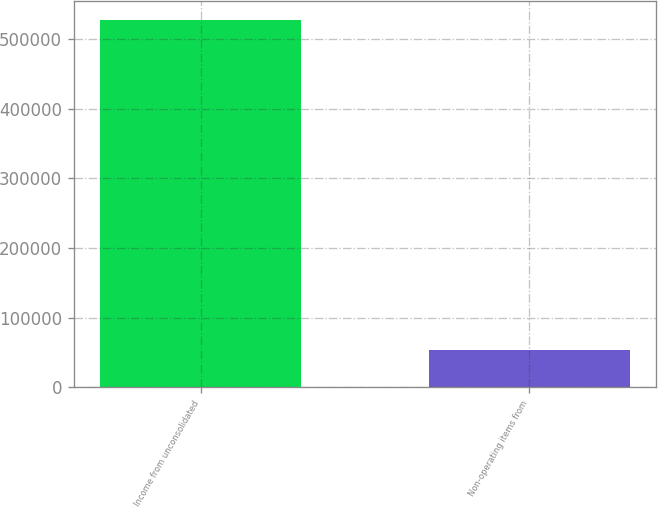<chart> <loc_0><loc_0><loc_500><loc_500><bar_chart><fcel>Income from unconsolidated<fcel>Non-operating items from<nl><fcel>527616<fcel>53139<nl></chart> 